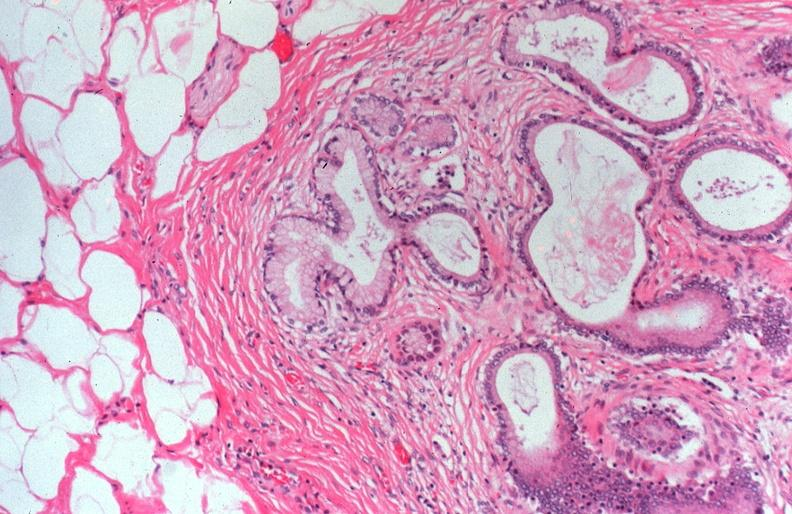s pancreas present?
Answer the question using a single word or phrase. Yes 